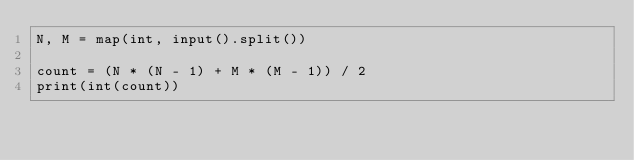Convert code to text. <code><loc_0><loc_0><loc_500><loc_500><_Python_>N, M = map(int, input().split())

count = (N * (N - 1) + M * (M - 1)) / 2
print(int(count))</code> 